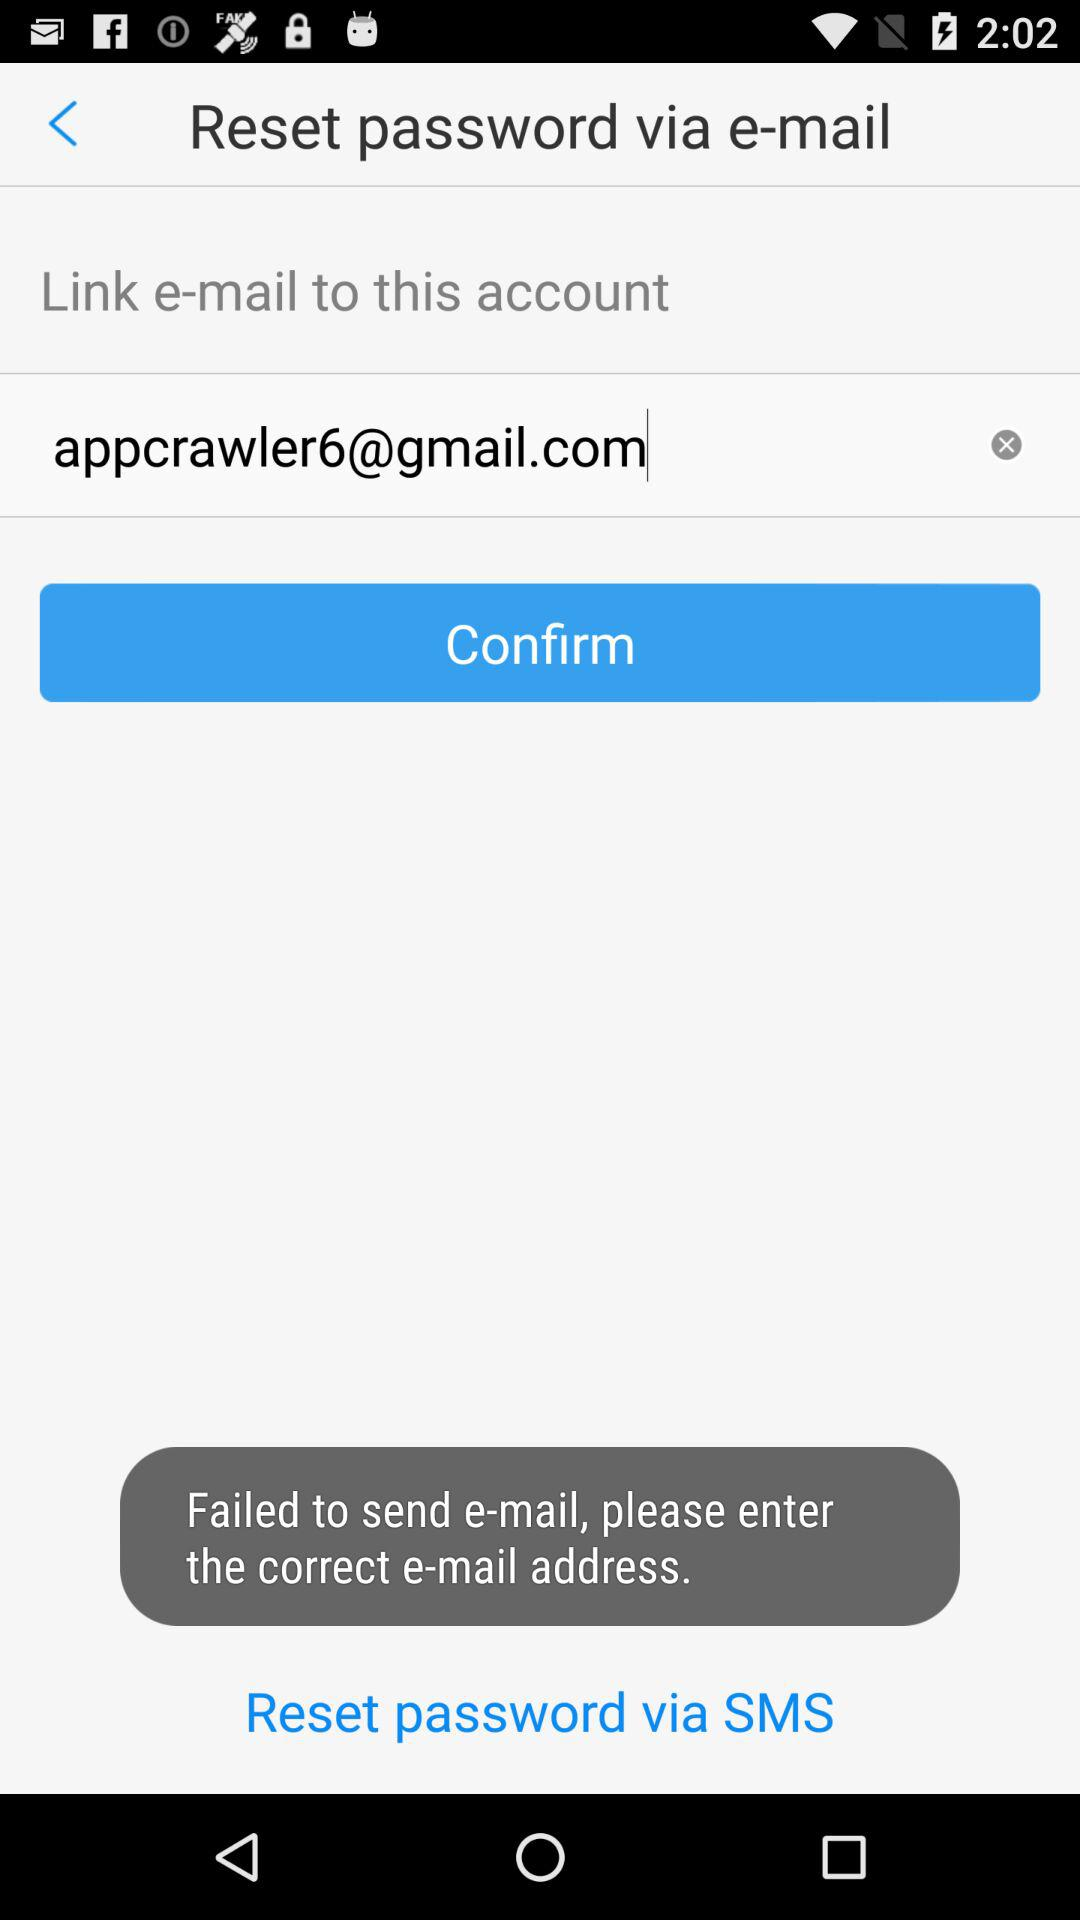What is the email address? The email address is appcrawler6@gmail.com. 